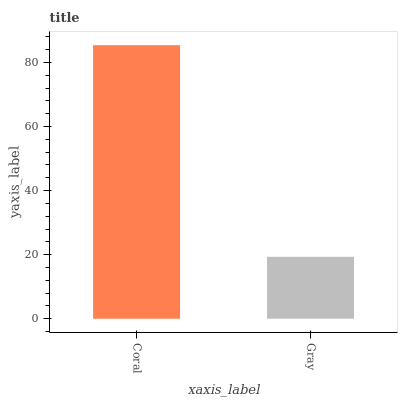Is Gray the minimum?
Answer yes or no. Yes. Is Coral the maximum?
Answer yes or no. Yes. Is Gray the maximum?
Answer yes or no. No. Is Coral greater than Gray?
Answer yes or no. Yes. Is Gray less than Coral?
Answer yes or no. Yes. Is Gray greater than Coral?
Answer yes or no. No. Is Coral less than Gray?
Answer yes or no. No. Is Coral the high median?
Answer yes or no. Yes. Is Gray the low median?
Answer yes or no. Yes. Is Gray the high median?
Answer yes or no. No. Is Coral the low median?
Answer yes or no. No. 